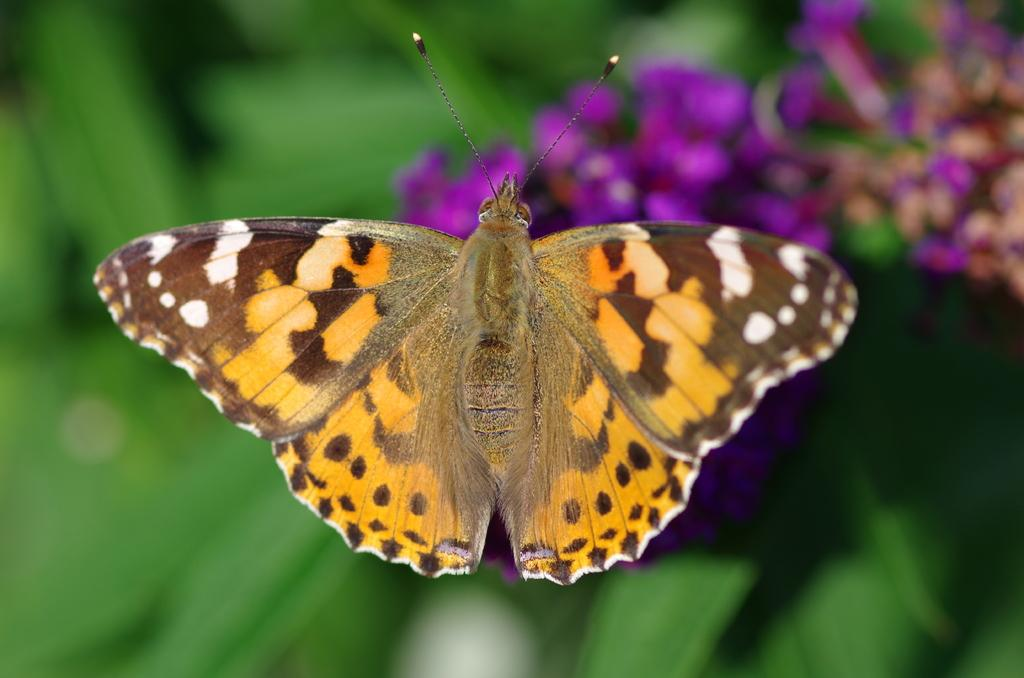What is the main subject of the image? There is a butterfly in the image. Can you describe the background of the image? The background of the image is blurred. What type of prose can be seen in the image? There is no prose present in the image; it features a butterfly and a blurred background. How many sticks are visible in the image? There are no sticks visible in the image. 